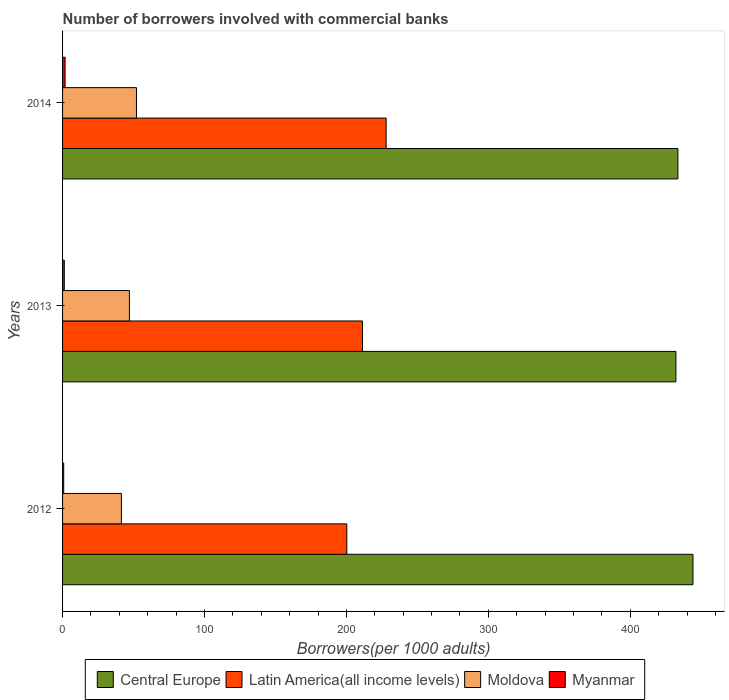Are the number of bars per tick equal to the number of legend labels?
Offer a very short reply. Yes. Are the number of bars on each tick of the Y-axis equal?
Give a very brief answer. Yes. How many bars are there on the 2nd tick from the top?
Provide a succinct answer. 4. What is the label of the 1st group of bars from the top?
Give a very brief answer. 2014. What is the number of borrowers involved with commercial banks in Myanmar in 2013?
Your answer should be compact. 1.22. Across all years, what is the maximum number of borrowers involved with commercial banks in Moldova?
Your response must be concise. 52.07. Across all years, what is the minimum number of borrowers involved with commercial banks in Moldova?
Your answer should be very brief. 41.47. In which year was the number of borrowers involved with commercial banks in Myanmar minimum?
Keep it short and to the point. 2012. What is the total number of borrowers involved with commercial banks in Moldova in the graph?
Your answer should be compact. 140.63. What is the difference between the number of borrowers involved with commercial banks in Myanmar in 2013 and that in 2014?
Your answer should be very brief. -0.55. What is the difference between the number of borrowers involved with commercial banks in Moldova in 2014 and the number of borrowers involved with commercial banks in Central Europe in 2013?
Keep it short and to the point. -380.11. What is the average number of borrowers involved with commercial banks in Central Europe per year?
Offer a terse response. 436.66. In the year 2012, what is the difference between the number of borrowers involved with commercial banks in Latin America(all income levels) and number of borrowers involved with commercial banks in Moldova?
Your response must be concise. 158.83. What is the ratio of the number of borrowers involved with commercial banks in Central Europe in 2012 to that in 2014?
Make the answer very short. 1.02. What is the difference between the highest and the second highest number of borrowers involved with commercial banks in Myanmar?
Give a very brief answer. 0.55. What is the difference between the highest and the lowest number of borrowers involved with commercial banks in Myanmar?
Give a very brief answer. 0.97. Is the sum of the number of borrowers involved with commercial banks in Central Europe in 2012 and 2013 greater than the maximum number of borrowers involved with commercial banks in Latin America(all income levels) across all years?
Your answer should be compact. Yes. What does the 4th bar from the top in 2013 represents?
Give a very brief answer. Central Europe. What does the 1st bar from the bottom in 2012 represents?
Ensure brevity in your answer.  Central Europe. Is it the case that in every year, the sum of the number of borrowers involved with commercial banks in Latin America(all income levels) and number of borrowers involved with commercial banks in Central Europe is greater than the number of borrowers involved with commercial banks in Moldova?
Your response must be concise. Yes. How many bars are there?
Your answer should be very brief. 12. Are all the bars in the graph horizontal?
Your answer should be very brief. Yes. What is the difference between two consecutive major ticks on the X-axis?
Provide a short and direct response. 100. Does the graph contain any zero values?
Provide a succinct answer. No. What is the title of the graph?
Your answer should be compact. Number of borrowers involved with commercial banks. Does "Central African Republic" appear as one of the legend labels in the graph?
Make the answer very short. No. What is the label or title of the X-axis?
Provide a short and direct response. Borrowers(per 1000 adults). What is the label or title of the Y-axis?
Give a very brief answer. Years. What is the Borrowers(per 1000 adults) in Central Europe in 2012?
Provide a short and direct response. 444.21. What is the Borrowers(per 1000 adults) of Latin America(all income levels) in 2012?
Ensure brevity in your answer.  200.29. What is the Borrowers(per 1000 adults) in Moldova in 2012?
Ensure brevity in your answer.  41.47. What is the Borrowers(per 1000 adults) in Myanmar in 2012?
Offer a terse response. 0.8. What is the Borrowers(per 1000 adults) of Central Europe in 2013?
Your response must be concise. 432.18. What is the Borrowers(per 1000 adults) in Latin America(all income levels) in 2013?
Ensure brevity in your answer.  211.32. What is the Borrowers(per 1000 adults) in Moldova in 2013?
Keep it short and to the point. 47.09. What is the Borrowers(per 1000 adults) in Myanmar in 2013?
Make the answer very short. 1.22. What is the Borrowers(per 1000 adults) in Central Europe in 2014?
Provide a succinct answer. 433.59. What is the Borrowers(per 1000 adults) in Latin America(all income levels) in 2014?
Provide a succinct answer. 228. What is the Borrowers(per 1000 adults) of Moldova in 2014?
Keep it short and to the point. 52.07. What is the Borrowers(per 1000 adults) of Myanmar in 2014?
Your answer should be compact. 1.77. Across all years, what is the maximum Borrowers(per 1000 adults) of Central Europe?
Provide a succinct answer. 444.21. Across all years, what is the maximum Borrowers(per 1000 adults) in Latin America(all income levels)?
Keep it short and to the point. 228. Across all years, what is the maximum Borrowers(per 1000 adults) of Moldova?
Offer a very short reply. 52.07. Across all years, what is the maximum Borrowers(per 1000 adults) in Myanmar?
Your answer should be compact. 1.77. Across all years, what is the minimum Borrowers(per 1000 adults) in Central Europe?
Your answer should be very brief. 432.18. Across all years, what is the minimum Borrowers(per 1000 adults) of Latin America(all income levels)?
Your answer should be compact. 200.29. Across all years, what is the minimum Borrowers(per 1000 adults) of Moldova?
Offer a very short reply. 41.47. Across all years, what is the minimum Borrowers(per 1000 adults) of Myanmar?
Provide a short and direct response. 0.8. What is the total Borrowers(per 1000 adults) in Central Europe in the graph?
Make the answer very short. 1309.98. What is the total Borrowers(per 1000 adults) in Latin America(all income levels) in the graph?
Your response must be concise. 639.61. What is the total Borrowers(per 1000 adults) in Moldova in the graph?
Offer a terse response. 140.63. What is the total Borrowers(per 1000 adults) of Myanmar in the graph?
Give a very brief answer. 3.78. What is the difference between the Borrowers(per 1000 adults) in Central Europe in 2012 and that in 2013?
Provide a short and direct response. 12.02. What is the difference between the Borrowers(per 1000 adults) of Latin America(all income levels) in 2012 and that in 2013?
Provide a short and direct response. -11.03. What is the difference between the Borrowers(per 1000 adults) in Moldova in 2012 and that in 2013?
Your response must be concise. -5.63. What is the difference between the Borrowers(per 1000 adults) in Myanmar in 2012 and that in 2013?
Your response must be concise. -0.42. What is the difference between the Borrowers(per 1000 adults) in Central Europe in 2012 and that in 2014?
Provide a succinct answer. 10.62. What is the difference between the Borrowers(per 1000 adults) of Latin America(all income levels) in 2012 and that in 2014?
Ensure brevity in your answer.  -27.7. What is the difference between the Borrowers(per 1000 adults) of Moldova in 2012 and that in 2014?
Give a very brief answer. -10.61. What is the difference between the Borrowers(per 1000 adults) of Myanmar in 2012 and that in 2014?
Offer a very short reply. -0.97. What is the difference between the Borrowers(per 1000 adults) of Central Europe in 2013 and that in 2014?
Make the answer very short. -1.41. What is the difference between the Borrowers(per 1000 adults) of Latin America(all income levels) in 2013 and that in 2014?
Provide a short and direct response. -16.68. What is the difference between the Borrowers(per 1000 adults) of Moldova in 2013 and that in 2014?
Offer a very short reply. -4.98. What is the difference between the Borrowers(per 1000 adults) of Myanmar in 2013 and that in 2014?
Give a very brief answer. -0.55. What is the difference between the Borrowers(per 1000 adults) in Central Europe in 2012 and the Borrowers(per 1000 adults) in Latin America(all income levels) in 2013?
Your answer should be very brief. 232.89. What is the difference between the Borrowers(per 1000 adults) in Central Europe in 2012 and the Borrowers(per 1000 adults) in Moldova in 2013?
Your answer should be very brief. 397.11. What is the difference between the Borrowers(per 1000 adults) of Central Europe in 2012 and the Borrowers(per 1000 adults) of Myanmar in 2013?
Offer a terse response. 442.99. What is the difference between the Borrowers(per 1000 adults) of Latin America(all income levels) in 2012 and the Borrowers(per 1000 adults) of Moldova in 2013?
Offer a very short reply. 153.2. What is the difference between the Borrowers(per 1000 adults) of Latin America(all income levels) in 2012 and the Borrowers(per 1000 adults) of Myanmar in 2013?
Provide a short and direct response. 199.08. What is the difference between the Borrowers(per 1000 adults) of Moldova in 2012 and the Borrowers(per 1000 adults) of Myanmar in 2013?
Offer a terse response. 40.25. What is the difference between the Borrowers(per 1000 adults) of Central Europe in 2012 and the Borrowers(per 1000 adults) of Latin America(all income levels) in 2014?
Give a very brief answer. 216.21. What is the difference between the Borrowers(per 1000 adults) of Central Europe in 2012 and the Borrowers(per 1000 adults) of Moldova in 2014?
Offer a terse response. 392.13. What is the difference between the Borrowers(per 1000 adults) of Central Europe in 2012 and the Borrowers(per 1000 adults) of Myanmar in 2014?
Your response must be concise. 442.44. What is the difference between the Borrowers(per 1000 adults) in Latin America(all income levels) in 2012 and the Borrowers(per 1000 adults) in Moldova in 2014?
Offer a very short reply. 148.22. What is the difference between the Borrowers(per 1000 adults) in Latin America(all income levels) in 2012 and the Borrowers(per 1000 adults) in Myanmar in 2014?
Provide a succinct answer. 198.53. What is the difference between the Borrowers(per 1000 adults) in Moldova in 2012 and the Borrowers(per 1000 adults) in Myanmar in 2014?
Keep it short and to the point. 39.7. What is the difference between the Borrowers(per 1000 adults) in Central Europe in 2013 and the Borrowers(per 1000 adults) in Latin America(all income levels) in 2014?
Give a very brief answer. 204.19. What is the difference between the Borrowers(per 1000 adults) of Central Europe in 2013 and the Borrowers(per 1000 adults) of Moldova in 2014?
Keep it short and to the point. 380.11. What is the difference between the Borrowers(per 1000 adults) of Central Europe in 2013 and the Borrowers(per 1000 adults) of Myanmar in 2014?
Your response must be concise. 430.42. What is the difference between the Borrowers(per 1000 adults) in Latin America(all income levels) in 2013 and the Borrowers(per 1000 adults) in Moldova in 2014?
Offer a very short reply. 159.25. What is the difference between the Borrowers(per 1000 adults) in Latin America(all income levels) in 2013 and the Borrowers(per 1000 adults) in Myanmar in 2014?
Your response must be concise. 209.56. What is the difference between the Borrowers(per 1000 adults) in Moldova in 2013 and the Borrowers(per 1000 adults) in Myanmar in 2014?
Ensure brevity in your answer.  45.33. What is the average Borrowers(per 1000 adults) in Central Europe per year?
Your response must be concise. 436.66. What is the average Borrowers(per 1000 adults) of Latin America(all income levels) per year?
Your answer should be compact. 213.2. What is the average Borrowers(per 1000 adults) in Moldova per year?
Keep it short and to the point. 46.88. What is the average Borrowers(per 1000 adults) in Myanmar per year?
Make the answer very short. 1.26. In the year 2012, what is the difference between the Borrowers(per 1000 adults) in Central Europe and Borrowers(per 1000 adults) in Latin America(all income levels)?
Provide a short and direct response. 243.91. In the year 2012, what is the difference between the Borrowers(per 1000 adults) in Central Europe and Borrowers(per 1000 adults) in Moldova?
Make the answer very short. 402.74. In the year 2012, what is the difference between the Borrowers(per 1000 adults) of Central Europe and Borrowers(per 1000 adults) of Myanmar?
Your answer should be very brief. 443.41. In the year 2012, what is the difference between the Borrowers(per 1000 adults) of Latin America(all income levels) and Borrowers(per 1000 adults) of Moldova?
Keep it short and to the point. 158.83. In the year 2012, what is the difference between the Borrowers(per 1000 adults) in Latin America(all income levels) and Borrowers(per 1000 adults) in Myanmar?
Ensure brevity in your answer.  199.5. In the year 2012, what is the difference between the Borrowers(per 1000 adults) in Moldova and Borrowers(per 1000 adults) in Myanmar?
Your response must be concise. 40.67. In the year 2013, what is the difference between the Borrowers(per 1000 adults) of Central Europe and Borrowers(per 1000 adults) of Latin America(all income levels)?
Provide a short and direct response. 220.86. In the year 2013, what is the difference between the Borrowers(per 1000 adults) in Central Europe and Borrowers(per 1000 adults) in Moldova?
Make the answer very short. 385.09. In the year 2013, what is the difference between the Borrowers(per 1000 adults) in Central Europe and Borrowers(per 1000 adults) in Myanmar?
Keep it short and to the point. 430.97. In the year 2013, what is the difference between the Borrowers(per 1000 adults) of Latin America(all income levels) and Borrowers(per 1000 adults) of Moldova?
Offer a terse response. 164.23. In the year 2013, what is the difference between the Borrowers(per 1000 adults) of Latin America(all income levels) and Borrowers(per 1000 adults) of Myanmar?
Your response must be concise. 210.1. In the year 2013, what is the difference between the Borrowers(per 1000 adults) of Moldova and Borrowers(per 1000 adults) of Myanmar?
Keep it short and to the point. 45.88. In the year 2014, what is the difference between the Borrowers(per 1000 adults) of Central Europe and Borrowers(per 1000 adults) of Latin America(all income levels)?
Your answer should be very brief. 205.59. In the year 2014, what is the difference between the Borrowers(per 1000 adults) in Central Europe and Borrowers(per 1000 adults) in Moldova?
Make the answer very short. 381.52. In the year 2014, what is the difference between the Borrowers(per 1000 adults) in Central Europe and Borrowers(per 1000 adults) in Myanmar?
Keep it short and to the point. 431.82. In the year 2014, what is the difference between the Borrowers(per 1000 adults) in Latin America(all income levels) and Borrowers(per 1000 adults) in Moldova?
Your answer should be very brief. 175.92. In the year 2014, what is the difference between the Borrowers(per 1000 adults) of Latin America(all income levels) and Borrowers(per 1000 adults) of Myanmar?
Provide a succinct answer. 226.23. In the year 2014, what is the difference between the Borrowers(per 1000 adults) in Moldova and Borrowers(per 1000 adults) in Myanmar?
Your answer should be very brief. 50.31. What is the ratio of the Borrowers(per 1000 adults) of Central Europe in 2012 to that in 2013?
Your response must be concise. 1.03. What is the ratio of the Borrowers(per 1000 adults) in Latin America(all income levels) in 2012 to that in 2013?
Keep it short and to the point. 0.95. What is the ratio of the Borrowers(per 1000 adults) of Moldova in 2012 to that in 2013?
Provide a short and direct response. 0.88. What is the ratio of the Borrowers(per 1000 adults) in Myanmar in 2012 to that in 2013?
Offer a terse response. 0.65. What is the ratio of the Borrowers(per 1000 adults) of Central Europe in 2012 to that in 2014?
Keep it short and to the point. 1.02. What is the ratio of the Borrowers(per 1000 adults) in Latin America(all income levels) in 2012 to that in 2014?
Your response must be concise. 0.88. What is the ratio of the Borrowers(per 1000 adults) in Moldova in 2012 to that in 2014?
Offer a very short reply. 0.8. What is the ratio of the Borrowers(per 1000 adults) of Myanmar in 2012 to that in 2014?
Ensure brevity in your answer.  0.45. What is the ratio of the Borrowers(per 1000 adults) of Central Europe in 2013 to that in 2014?
Offer a very short reply. 1. What is the ratio of the Borrowers(per 1000 adults) in Latin America(all income levels) in 2013 to that in 2014?
Give a very brief answer. 0.93. What is the ratio of the Borrowers(per 1000 adults) of Moldova in 2013 to that in 2014?
Make the answer very short. 0.9. What is the ratio of the Borrowers(per 1000 adults) of Myanmar in 2013 to that in 2014?
Provide a succinct answer. 0.69. What is the difference between the highest and the second highest Borrowers(per 1000 adults) of Central Europe?
Your answer should be very brief. 10.62. What is the difference between the highest and the second highest Borrowers(per 1000 adults) in Latin America(all income levels)?
Make the answer very short. 16.68. What is the difference between the highest and the second highest Borrowers(per 1000 adults) of Moldova?
Your answer should be very brief. 4.98. What is the difference between the highest and the second highest Borrowers(per 1000 adults) of Myanmar?
Provide a succinct answer. 0.55. What is the difference between the highest and the lowest Borrowers(per 1000 adults) of Central Europe?
Make the answer very short. 12.02. What is the difference between the highest and the lowest Borrowers(per 1000 adults) in Latin America(all income levels)?
Your answer should be compact. 27.7. What is the difference between the highest and the lowest Borrowers(per 1000 adults) of Moldova?
Offer a very short reply. 10.61. What is the difference between the highest and the lowest Borrowers(per 1000 adults) of Myanmar?
Provide a short and direct response. 0.97. 